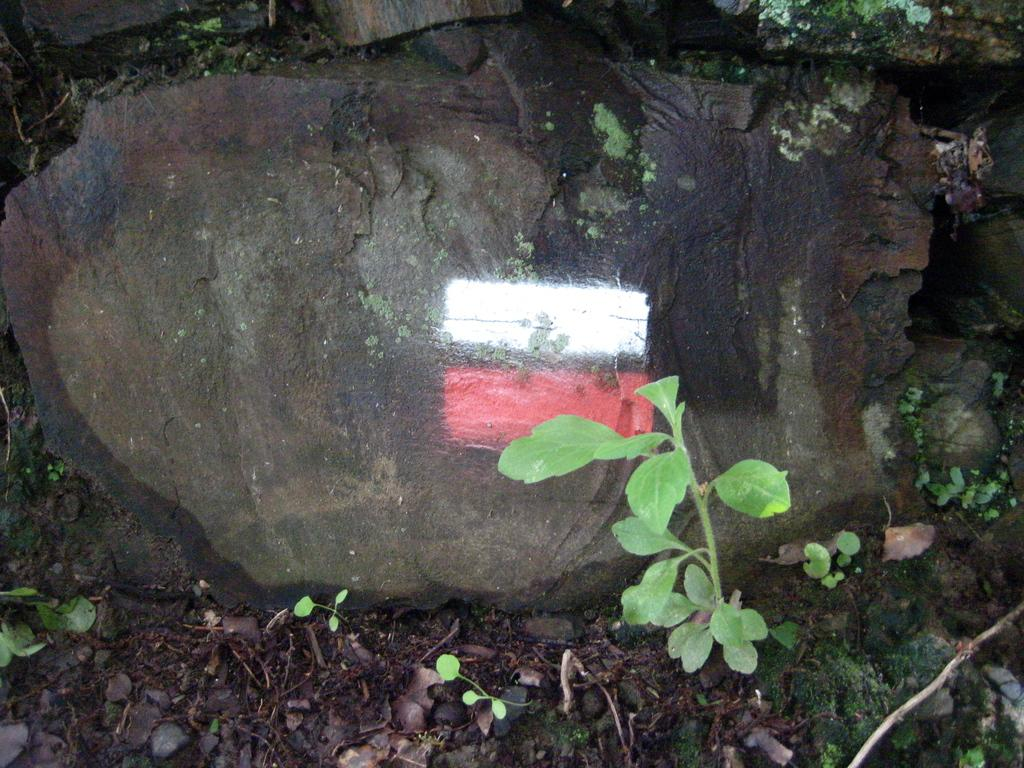What is the main object in the image? There is a stone in the image. What colors are present on the stone? There are white and red color lines on the stone. What type of vegetation is visible at the bottom of the image? There are plants at the bottom of the image. What part of the plants can be seen in the image? Leaves are present in the image. What type of can is shown on the stone in the image? There is no can present on the stone in the image. What message does the flag on the stone convey in the image? There is no flag present on the stone in the image. 